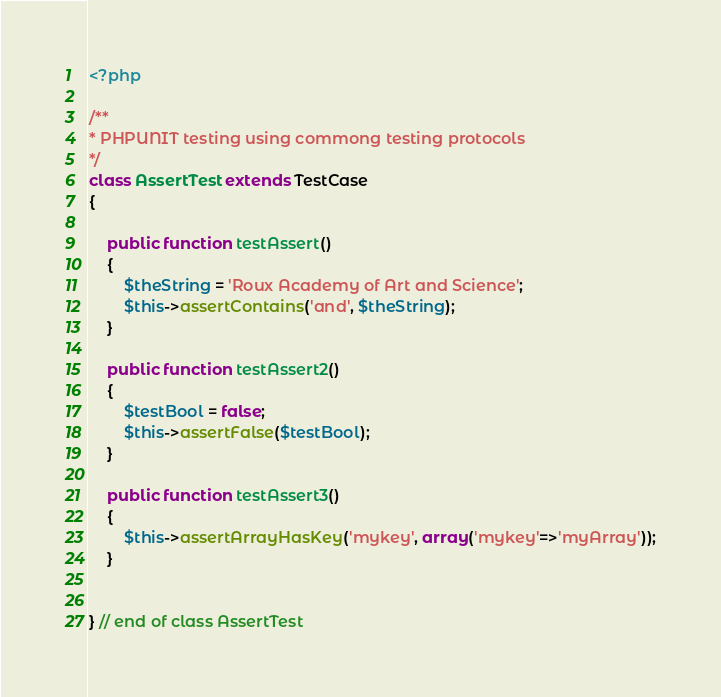Convert code to text. <code><loc_0><loc_0><loc_500><loc_500><_PHP_><?php 

/**
* PHPUNIT testing using commong testing protocols
*/
class AssertTest extends TestCase
{
	
	public function testAssert()
	{
		$theString = 'Roux Academy of Art and Science';
		$this->assertContains('and', $theString);
	}

	public function testAssert2()
	{
		$testBool = false;
		$this->assertFalse($testBool);
	}

	public function testAssert3()
	{
		$this->assertArrayHasKey('mykey', array('mykey'=>'myArray'));
	}


} // end of class AssertTest
</code> 